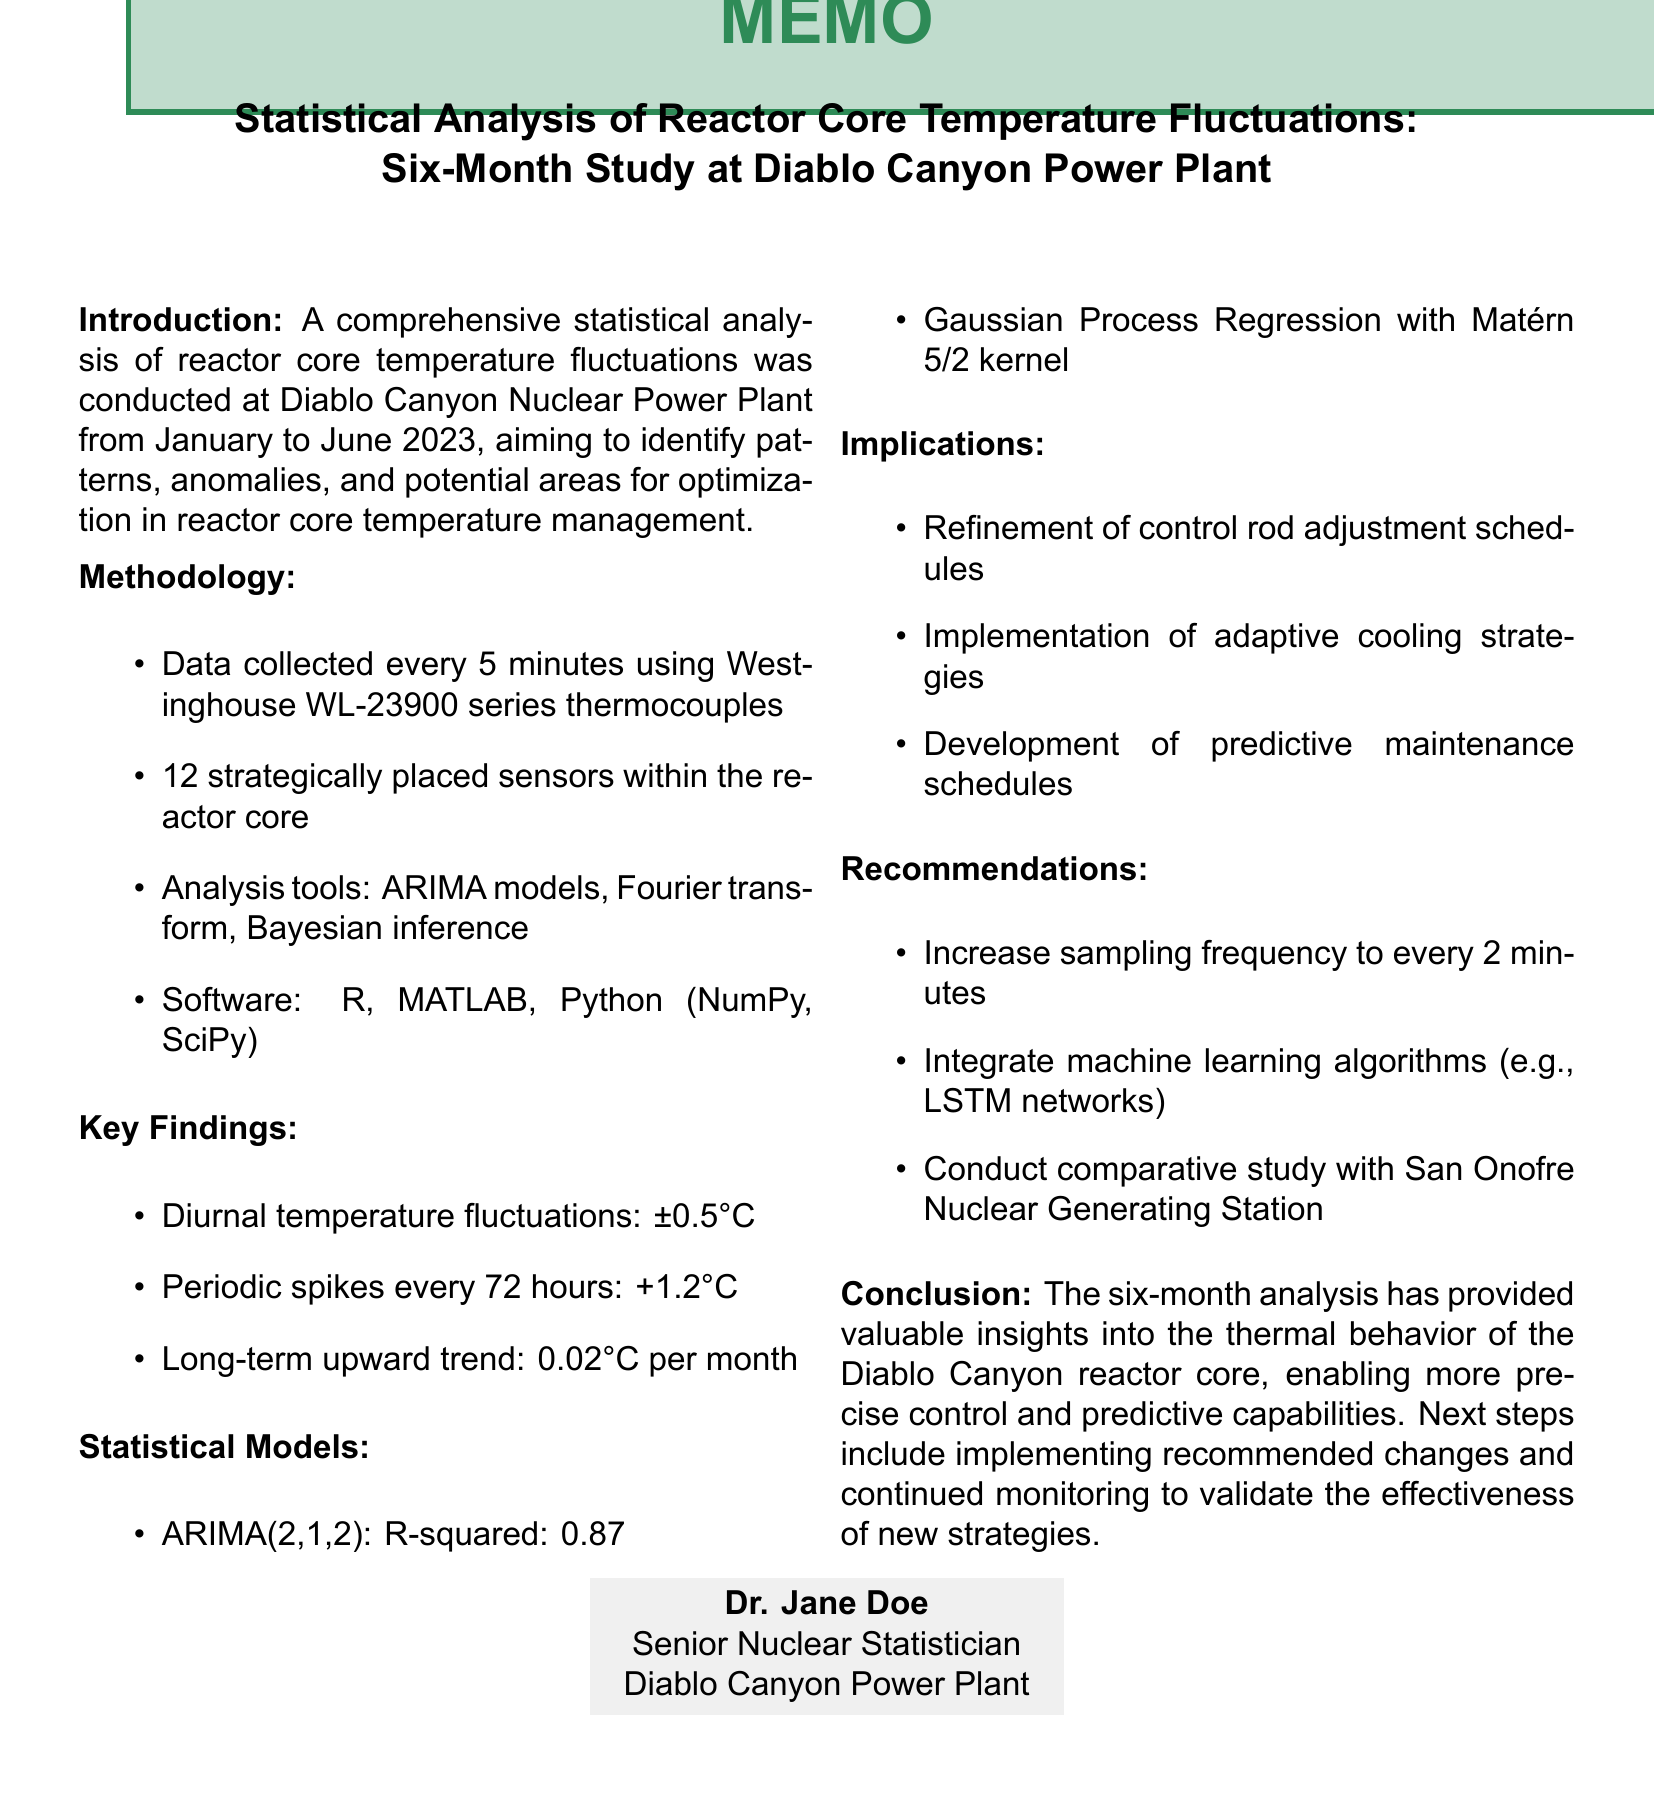What was the duration of the study? The study was conducted over a period from January to June 2023.
Answer: Six months How frequently were temperature measurements taken? The document states that measurements were taken every 5 minutes.
Answer: Every 5 minutes What statistical model had an R-squared value of 0.87? This model type is identified as ARIMA(2,1,2) in the document.
Answer: ARIMA(2,1,2) What was identified as a probable cause for periodic temperature spikes? The document mentions that scheduled control rod adjustments likely caused these spikes.
Answer: Scheduled control rod adjustments What is the long-term upward trend in temperature according to the findings? The document specifies this trend as 0.02°C per month.
Answer: 0.02°C per month What software was used for the statistical analysis? The document lists R Statistical Software, MATLAB, and Python with NumPy and SciPy as the software used.
Answer: R, MATLAB, Python What is one of the recommended changes for temperature monitoring? The recommendation suggests increasing the sampling frequency to improve analysis.
Answer: Increase sampling frequency to every 2 minutes What implication relates specifically to control rod schedules? The document states that control rod adjustment schedules should be refined as an implication of the findings.
Answer: Refinement of control rod adjustment schedules What overall conclusion is drawn from the six-month analysis? The document summarizes the conclusion as providing valuable insights into thermal behavior for better control.
Answer: Provided valuable insights into thermal behavior 